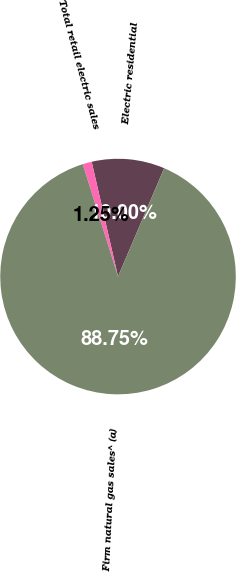Convert chart. <chart><loc_0><loc_0><loc_500><loc_500><pie_chart><fcel>Electric residential<fcel>Total retail electric sales<fcel>Firm natural gas sales^ (a)<nl><fcel>10.0%<fcel>1.25%<fcel>88.75%<nl></chart> 